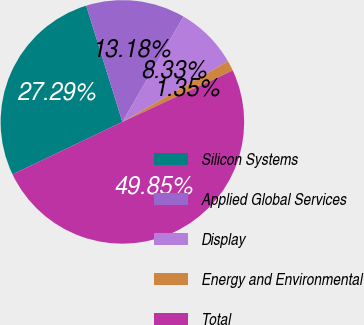<chart> <loc_0><loc_0><loc_500><loc_500><pie_chart><fcel>Silicon Systems<fcel>Applied Global Services<fcel>Display<fcel>Energy and Environmental<fcel>Total<nl><fcel>27.29%<fcel>13.18%<fcel>8.33%<fcel>1.35%<fcel>49.85%<nl></chart> 